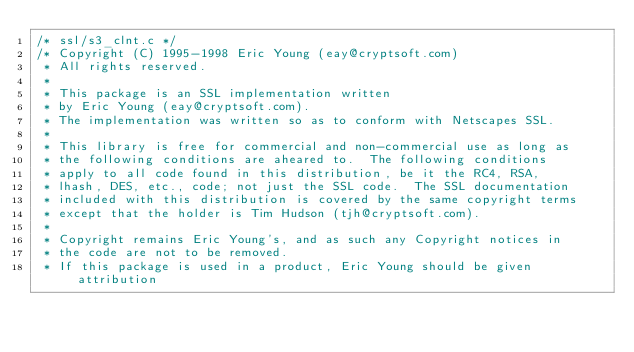Convert code to text. <code><loc_0><loc_0><loc_500><loc_500><_C_>/* ssl/s3_clnt.c */
/* Copyright (C) 1995-1998 Eric Young (eay@cryptsoft.com)
 * All rights reserved.
 *
 * This package is an SSL implementation written
 * by Eric Young (eay@cryptsoft.com).
 * The implementation was written so as to conform with Netscapes SSL.
 * 
 * This library is free for commercial and non-commercial use as long as
 * the following conditions are aheared to.  The following conditions
 * apply to all code found in this distribution, be it the RC4, RSA,
 * lhash, DES, etc., code; not just the SSL code.  The SSL documentation
 * included with this distribution is covered by the same copyright terms
 * except that the holder is Tim Hudson (tjh@cryptsoft.com).
 * 
 * Copyright remains Eric Young's, and as such any Copyright notices in
 * the code are not to be removed.
 * If this package is used in a product, Eric Young should be given attribution</code> 